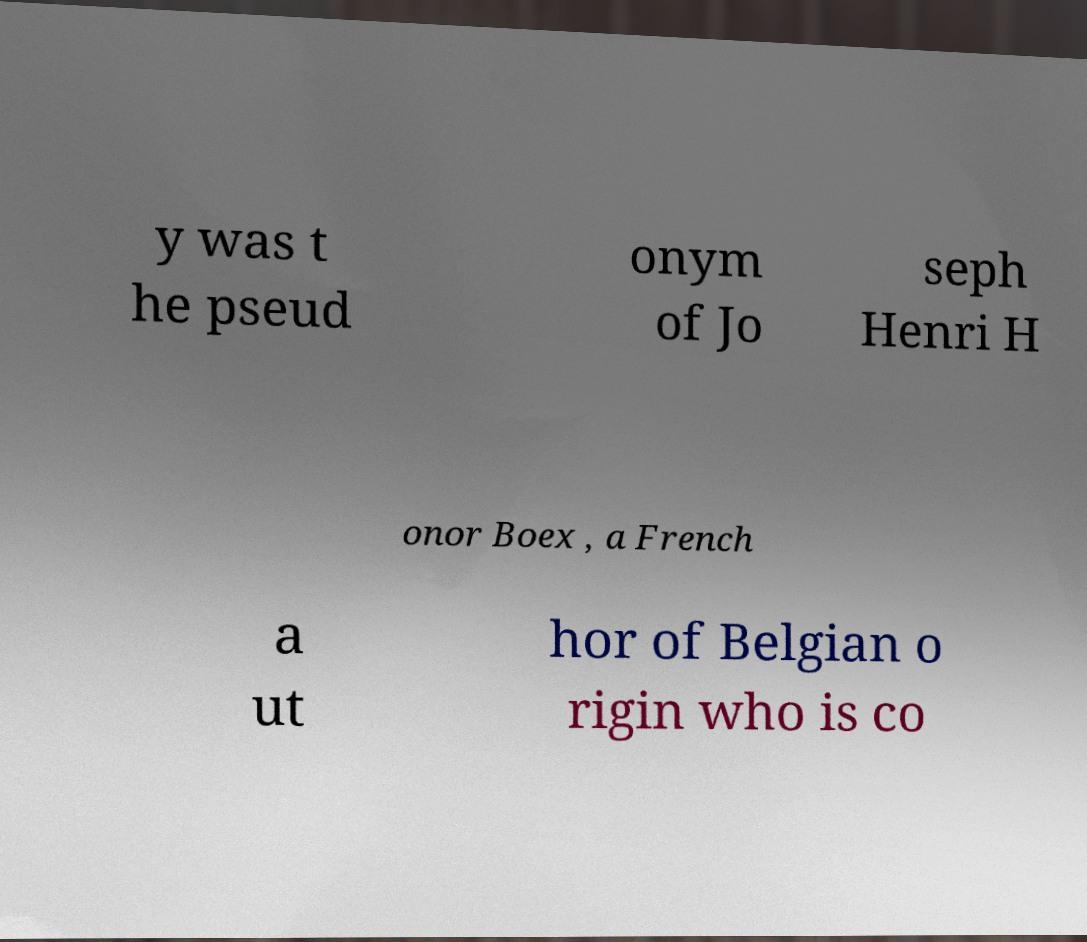Please read and relay the text visible in this image. What does it say? y was t he pseud onym of Jo seph Henri H onor Boex , a French a ut hor of Belgian o rigin who is co 